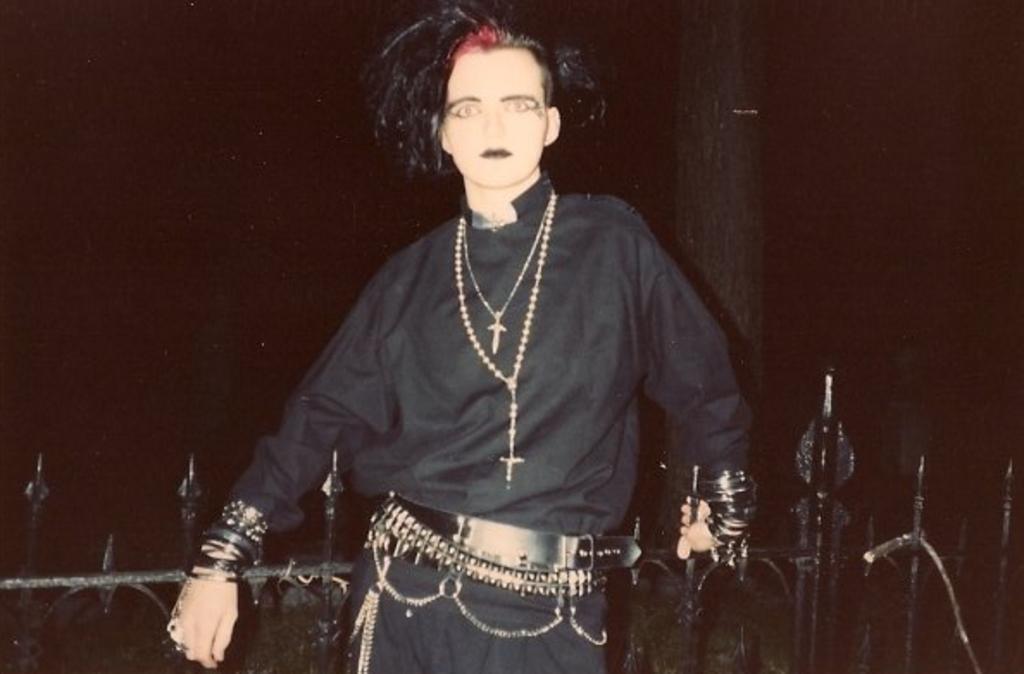Describe this image in one or two sentences. In this image, I can see a person standing. These look like the iron grilles. I think it is a tree trunk. The background looks dark. 